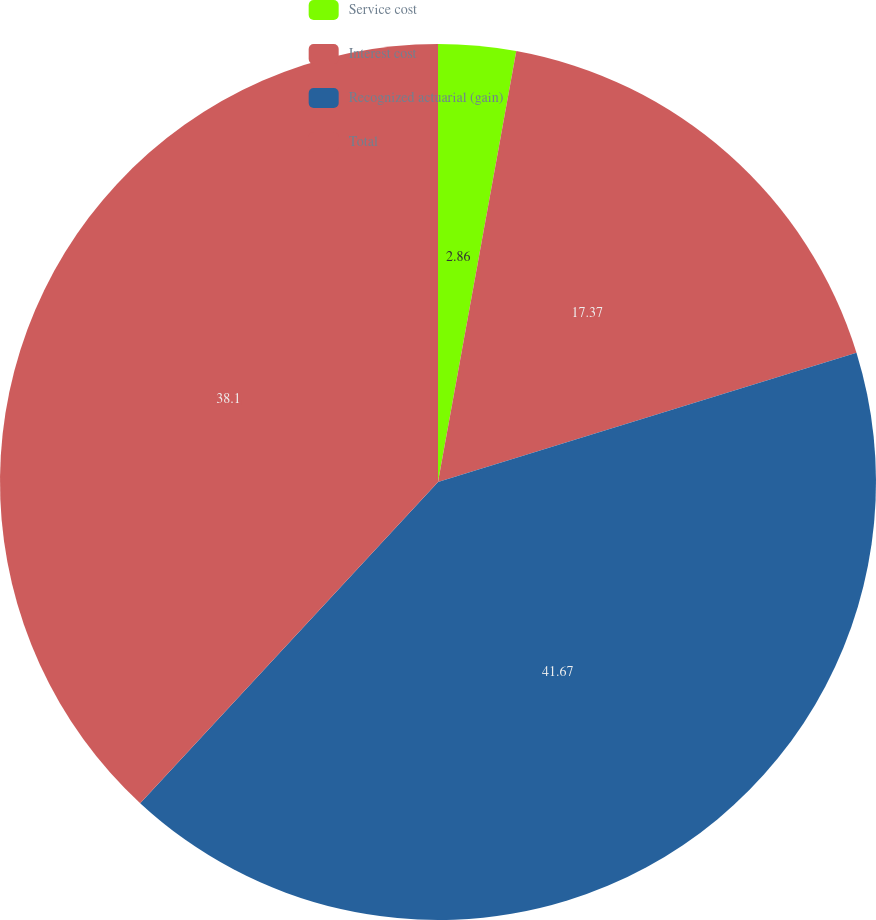Convert chart. <chart><loc_0><loc_0><loc_500><loc_500><pie_chart><fcel>Service cost<fcel>Interest cost<fcel>Recognized actuarial (gain)<fcel>Total<nl><fcel>2.86%<fcel>17.37%<fcel>41.67%<fcel>38.1%<nl></chart> 